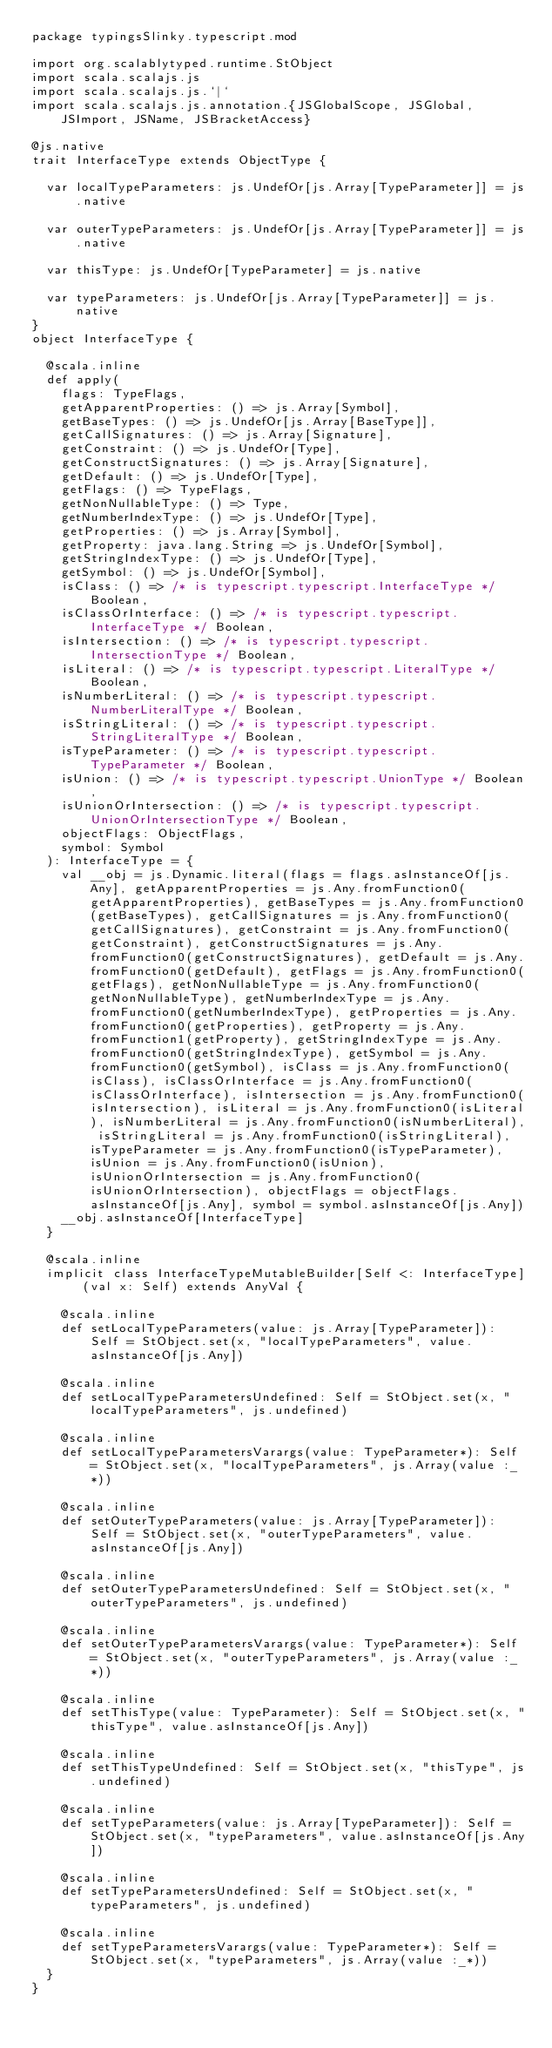<code> <loc_0><loc_0><loc_500><loc_500><_Scala_>package typingsSlinky.typescript.mod

import org.scalablytyped.runtime.StObject
import scala.scalajs.js
import scala.scalajs.js.`|`
import scala.scalajs.js.annotation.{JSGlobalScope, JSGlobal, JSImport, JSName, JSBracketAccess}

@js.native
trait InterfaceType extends ObjectType {
  
  var localTypeParameters: js.UndefOr[js.Array[TypeParameter]] = js.native
  
  var outerTypeParameters: js.UndefOr[js.Array[TypeParameter]] = js.native
  
  var thisType: js.UndefOr[TypeParameter] = js.native
  
  var typeParameters: js.UndefOr[js.Array[TypeParameter]] = js.native
}
object InterfaceType {
  
  @scala.inline
  def apply(
    flags: TypeFlags,
    getApparentProperties: () => js.Array[Symbol],
    getBaseTypes: () => js.UndefOr[js.Array[BaseType]],
    getCallSignatures: () => js.Array[Signature],
    getConstraint: () => js.UndefOr[Type],
    getConstructSignatures: () => js.Array[Signature],
    getDefault: () => js.UndefOr[Type],
    getFlags: () => TypeFlags,
    getNonNullableType: () => Type,
    getNumberIndexType: () => js.UndefOr[Type],
    getProperties: () => js.Array[Symbol],
    getProperty: java.lang.String => js.UndefOr[Symbol],
    getStringIndexType: () => js.UndefOr[Type],
    getSymbol: () => js.UndefOr[Symbol],
    isClass: () => /* is typescript.typescript.InterfaceType */ Boolean,
    isClassOrInterface: () => /* is typescript.typescript.InterfaceType */ Boolean,
    isIntersection: () => /* is typescript.typescript.IntersectionType */ Boolean,
    isLiteral: () => /* is typescript.typescript.LiteralType */ Boolean,
    isNumberLiteral: () => /* is typescript.typescript.NumberLiteralType */ Boolean,
    isStringLiteral: () => /* is typescript.typescript.StringLiteralType */ Boolean,
    isTypeParameter: () => /* is typescript.typescript.TypeParameter */ Boolean,
    isUnion: () => /* is typescript.typescript.UnionType */ Boolean,
    isUnionOrIntersection: () => /* is typescript.typescript.UnionOrIntersectionType */ Boolean,
    objectFlags: ObjectFlags,
    symbol: Symbol
  ): InterfaceType = {
    val __obj = js.Dynamic.literal(flags = flags.asInstanceOf[js.Any], getApparentProperties = js.Any.fromFunction0(getApparentProperties), getBaseTypes = js.Any.fromFunction0(getBaseTypes), getCallSignatures = js.Any.fromFunction0(getCallSignatures), getConstraint = js.Any.fromFunction0(getConstraint), getConstructSignatures = js.Any.fromFunction0(getConstructSignatures), getDefault = js.Any.fromFunction0(getDefault), getFlags = js.Any.fromFunction0(getFlags), getNonNullableType = js.Any.fromFunction0(getNonNullableType), getNumberIndexType = js.Any.fromFunction0(getNumberIndexType), getProperties = js.Any.fromFunction0(getProperties), getProperty = js.Any.fromFunction1(getProperty), getStringIndexType = js.Any.fromFunction0(getStringIndexType), getSymbol = js.Any.fromFunction0(getSymbol), isClass = js.Any.fromFunction0(isClass), isClassOrInterface = js.Any.fromFunction0(isClassOrInterface), isIntersection = js.Any.fromFunction0(isIntersection), isLiteral = js.Any.fromFunction0(isLiteral), isNumberLiteral = js.Any.fromFunction0(isNumberLiteral), isStringLiteral = js.Any.fromFunction0(isStringLiteral), isTypeParameter = js.Any.fromFunction0(isTypeParameter), isUnion = js.Any.fromFunction0(isUnion), isUnionOrIntersection = js.Any.fromFunction0(isUnionOrIntersection), objectFlags = objectFlags.asInstanceOf[js.Any], symbol = symbol.asInstanceOf[js.Any])
    __obj.asInstanceOf[InterfaceType]
  }
  
  @scala.inline
  implicit class InterfaceTypeMutableBuilder[Self <: InterfaceType] (val x: Self) extends AnyVal {
    
    @scala.inline
    def setLocalTypeParameters(value: js.Array[TypeParameter]): Self = StObject.set(x, "localTypeParameters", value.asInstanceOf[js.Any])
    
    @scala.inline
    def setLocalTypeParametersUndefined: Self = StObject.set(x, "localTypeParameters", js.undefined)
    
    @scala.inline
    def setLocalTypeParametersVarargs(value: TypeParameter*): Self = StObject.set(x, "localTypeParameters", js.Array(value :_*))
    
    @scala.inline
    def setOuterTypeParameters(value: js.Array[TypeParameter]): Self = StObject.set(x, "outerTypeParameters", value.asInstanceOf[js.Any])
    
    @scala.inline
    def setOuterTypeParametersUndefined: Self = StObject.set(x, "outerTypeParameters", js.undefined)
    
    @scala.inline
    def setOuterTypeParametersVarargs(value: TypeParameter*): Self = StObject.set(x, "outerTypeParameters", js.Array(value :_*))
    
    @scala.inline
    def setThisType(value: TypeParameter): Self = StObject.set(x, "thisType", value.asInstanceOf[js.Any])
    
    @scala.inline
    def setThisTypeUndefined: Self = StObject.set(x, "thisType", js.undefined)
    
    @scala.inline
    def setTypeParameters(value: js.Array[TypeParameter]): Self = StObject.set(x, "typeParameters", value.asInstanceOf[js.Any])
    
    @scala.inline
    def setTypeParametersUndefined: Self = StObject.set(x, "typeParameters", js.undefined)
    
    @scala.inline
    def setTypeParametersVarargs(value: TypeParameter*): Self = StObject.set(x, "typeParameters", js.Array(value :_*))
  }
}
</code> 